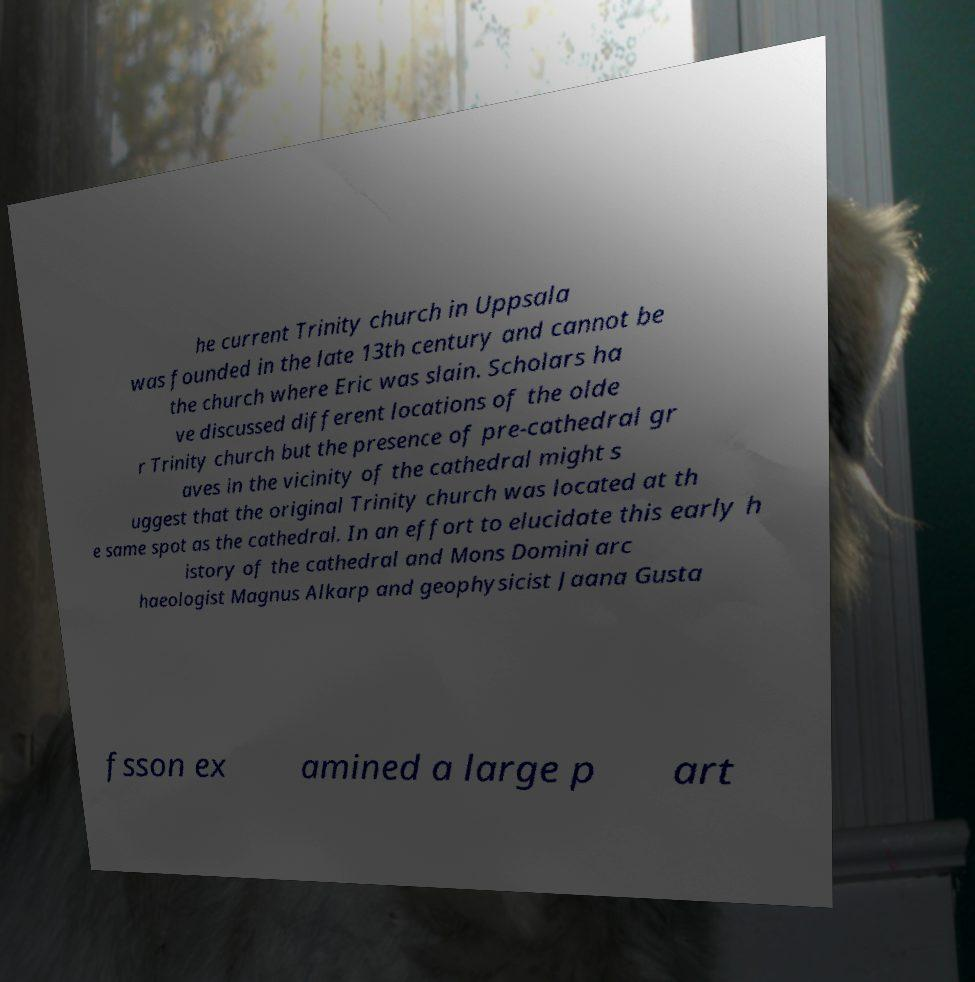Could you assist in decoding the text presented in this image and type it out clearly? he current Trinity church in Uppsala was founded in the late 13th century and cannot be the church where Eric was slain. Scholars ha ve discussed different locations of the olde r Trinity church but the presence of pre-cathedral gr aves in the vicinity of the cathedral might s uggest that the original Trinity church was located at th e same spot as the cathedral. In an effort to elucidate this early h istory of the cathedral and Mons Domini arc haeologist Magnus Alkarp and geophysicist Jaana Gusta fsson ex amined a large p art 